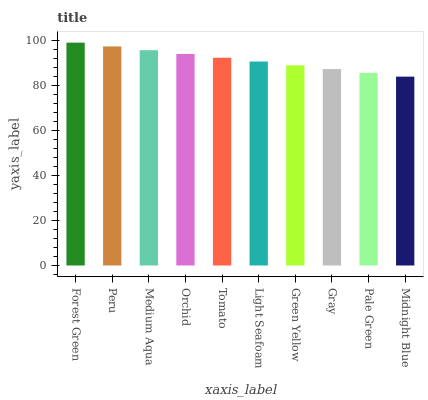Is Midnight Blue the minimum?
Answer yes or no. Yes. Is Forest Green the maximum?
Answer yes or no. Yes. Is Peru the minimum?
Answer yes or no. No. Is Peru the maximum?
Answer yes or no. No. Is Forest Green greater than Peru?
Answer yes or no. Yes. Is Peru less than Forest Green?
Answer yes or no. Yes. Is Peru greater than Forest Green?
Answer yes or no. No. Is Forest Green less than Peru?
Answer yes or no. No. Is Tomato the high median?
Answer yes or no. Yes. Is Light Seafoam the low median?
Answer yes or no. Yes. Is Forest Green the high median?
Answer yes or no. No. Is Orchid the low median?
Answer yes or no. No. 